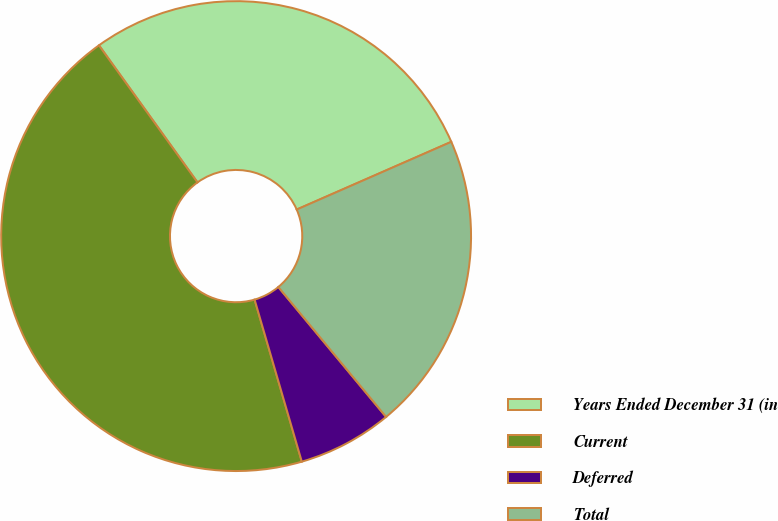<chart> <loc_0><loc_0><loc_500><loc_500><pie_chart><fcel>Years Ended December 31 (in<fcel>Current<fcel>Deferred<fcel>Total<nl><fcel>28.35%<fcel>44.59%<fcel>6.51%<fcel>20.55%<nl></chart> 